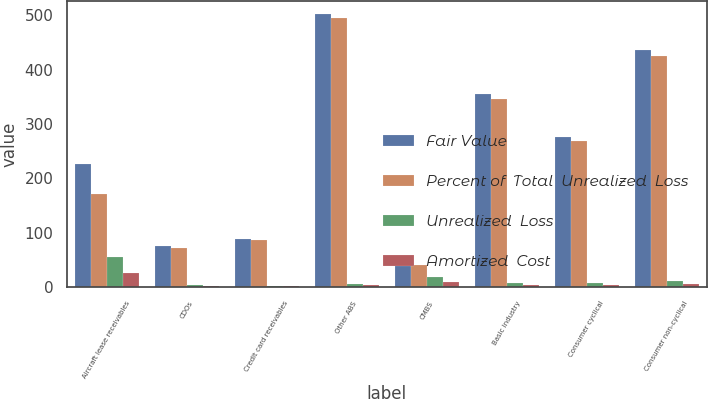<chart> <loc_0><loc_0><loc_500><loc_500><stacked_bar_chart><ecel><fcel>Aircraft lease receivables<fcel>CDOs<fcel>Credit card receivables<fcel>Other ABS<fcel>CMBS<fcel>Basic industry<fcel>Consumer cyclical<fcel>Consumer non-cyclical<nl><fcel>Fair Value<fcel>227<fcel>76<fcel>88<fcel>502<fcel>40.45<fcel>355<fcel>277<fcel>436<nl><fcel>Percent of  Total  Unrealized  Loss<fcel>172<fcel>72<fcel>86<fcel>496<fcel>40.45<fcel>347<fcel>269<fcel>425<nl><fcel>Unrealized  Loss<fcel>55<fcel>4<fcel>2<fcel>6<fcel>18<fcel>8<fcel>8<fcel>11<nl><fcel>Amortized  Cost<fcel>25.9<fcel>1.9<fcel>0.9<fcel>2.8<fcel>8.5<fcel>3.8<fcel>3.8<fcel>5.2<nl></chart> 